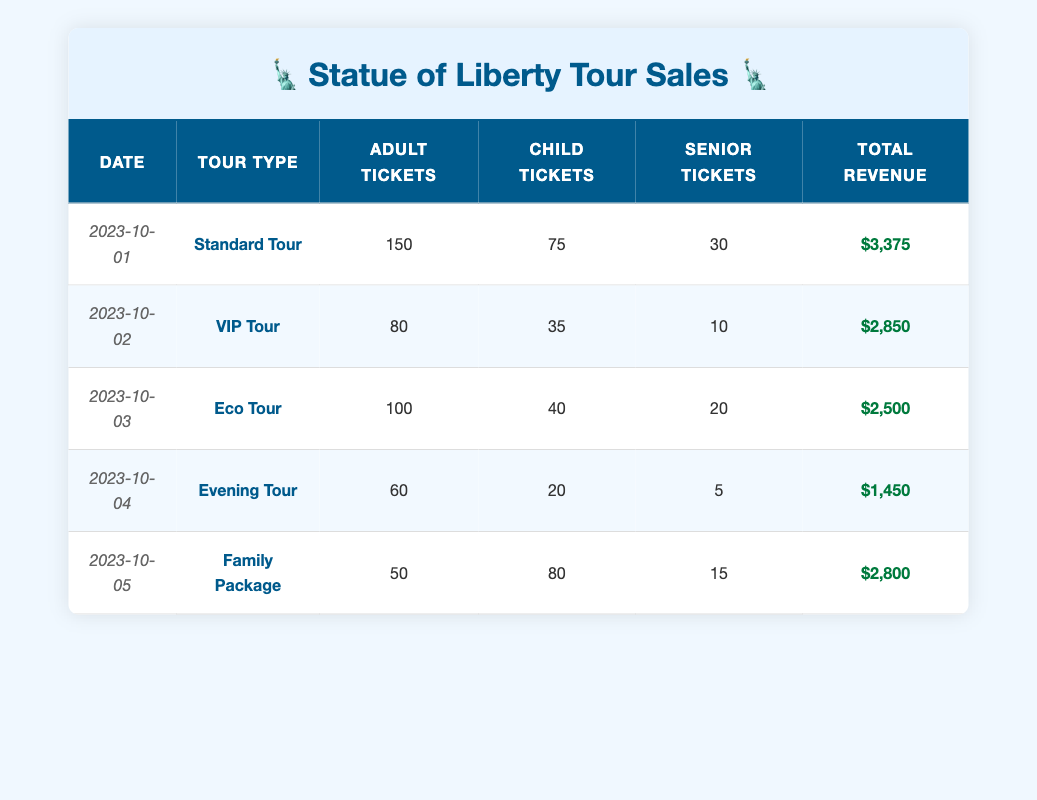What was the total revenue generated from ticket sales on October 1st? The total revenue from ticket sales for October 1st is listed as $3,375 in the table.
Answer: $3,375 How many adult tickets were sold for the Evening Tour? The Evening Tour had 60 adult tickets sold, as shown in the corresponding row for that tour.
Answer: 60 What is the combined total of child tickets sold for the Standard Tour and the Family Package? The Standard Tour had 75 child tickets sold and the Family Package had 80 child tickets sold. Combining these gives 75 + 80 = 155 child tickets sold in total.
Answer: 155 Is the total revenue from the VIP Tour greater than $2,500? The total revenue for the VIP Tour is $2,850. Since this is more than $2,500, the answer is yes.
Answer: Yes On what date was the lowest number of adult tickets sold, and how many were sold? The Evening Tour on October 4th had the lowest number of adult tickets sold at 60, compared to other tours on different dates.
Answer: October 4th, 60 What is the average number of senior tickets sold across all tour types? The total number of senior tickets sold is 30 + 10 + 20 + 5 + 15 = 80. There are 5 tours, so the average senior tickets sold is 80/5 = 16.
Answer: 16 Which tour type generated the highest revenue and what is that revenue? The highest revenue is from the Standard Tour, which generated $3,375, as per the figures listed.
Answer: $3,375 What is the difference in total revenue between the Eco Tour and the Evening Tour? The Eco Tour generated $2,500 and the Evening Tour generated $1,450. The difference is calculated as $2,500 - $1,450 = $1,050.
Answer: $1,050 Did any tour type sell more than 80 adult tickets? Yes, the Standard Tour sold 150 adult tickets, which is greater than 80.
Answer: Yes 